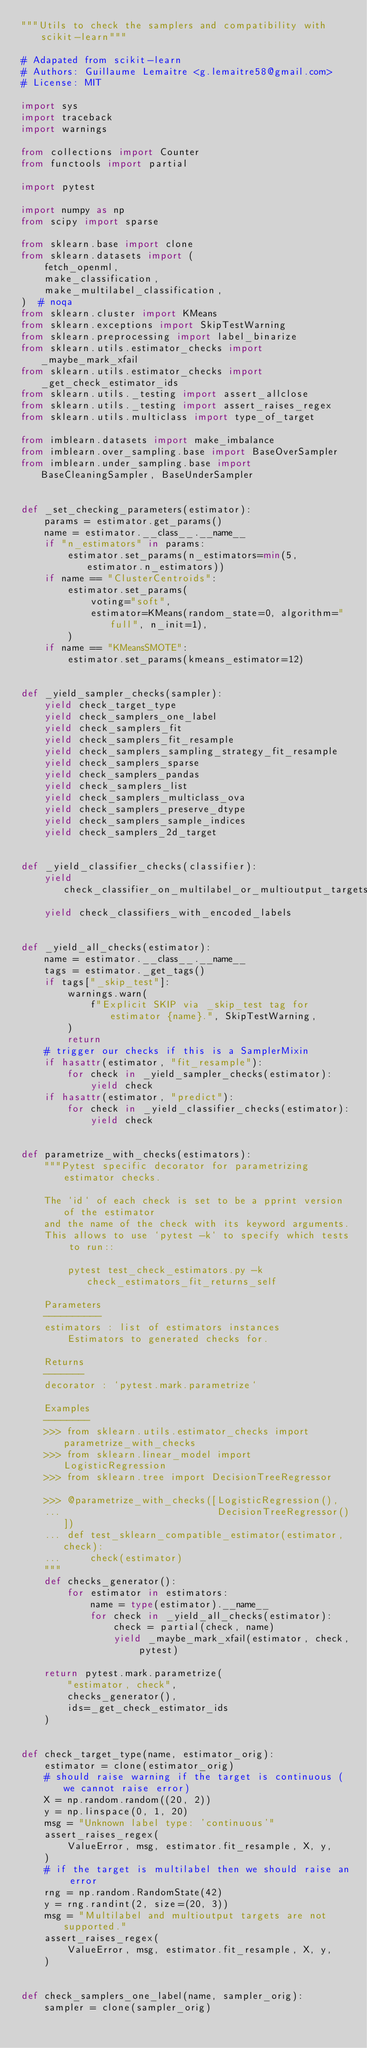<code> <loc_0><loc_0><loc_500><loc_500><_Python_>"""Utils to check the samplers and compatibility with scikit-learn"""

# Adapated from scikit-learn
# Authors: Guillaume Lemaitre <g.lemaitre58@gmail.com>
# License: MIT

import sys
import traceback
import warnings

from collections import Counter
from functools import partial

import pytest

import numpy as np
from scipy import sparse

from sklearn.base import clone
from sklearn.datasets import (
    fetch_openml,
    make_classification,
    make_multilabel_classification,
)  # noqa
from sklearn.cluster import KMeans
from sklearn.exceptions import SkipTestWarning
from sklearn.preprocessing import label_binarize
from sklearn.utils.estimator_checks import _maybe_mark_xfail
from sklearn.utils.estimator_checks import _get_check_estimator_ids
from sklearn.utils._testing import assert_allclose
from sklearn.utils._testing import assert_raises_regex
from sklearn.utils.multiclass import type_of_target

from imblearn.datasets import make_imbalance
from imblearn.over_sampling.base import BaseOverSampler
from imblearn.under_sampling.base import BaseCleaningSampler, BaseUnderSampler


def _set_checking_parameters(estimator):
    params = estimator.get_params()
    name = estimator.__class__.__name__
    if "n_estimators" in params:
        estimator.set_params(n_estimators=min(5, estimator.n_estimators))
    if name == "ClusterCentroids":
        estimator.set_params(
            voting="soft",
            estimator=KMeans(random_state=0, algorithm="full", n_init=1),
        )
    if name == "KMeansSMOTE":
        estimator.set_params(kmeans_estimator=12)


def _yield_sampler_checks(sampler):
    yield check_target_type
    yield check_samplers_one_label
    yield check_samplers_fit
    yield check_samplers_fit_resample
    yield check_samplers_sampling_strategy_fit_resample
    yield check_samplers_sparse
    yield check_samplers_pandas
    yield check_samplers_list
    yield check_samplers_multiclass_ova
    yield check_samplers_preserve_dtype
    yield check_samplers_sample_indices
    yield check_samplers_2d_target


def _yield_classifier_checks(classifier):
    yield check_classifier_on_multilabel_or_multioutput_targets
    yield check_classifiers_with_encoded_labels


def _yield_all_checks(estimator):
    name = estimator.__class__.__name__
    tags = estimator._get_tags()
    if tags["_skip_test"]:
        warnings.warn(
            f"Explicit SKIP via _skip_test tag for estimator {name}.", SkipTestWarning,
        )
        return
    # trigger our checks if this is a SamplerMixin
    if hasattr(estimator, "fit_resample"):
        for check in _yield_sampler_checks(estimator):
            yield check
    if hasattr(estimator, "predict"):
        for check in _yield_classifier_checks(estimator):
            yield check


def parametrize_with_checks(estimators):
    """Pytest specific decorator for parametrizing estimator checks.

    The `id` of each check is set to be a pprint version of the estimator
    and the name of the check with its keyword arguments.
    This allows to use `pytest -k` to specify which tests to run::

        pytest test_check_estimators.py -k check_estimators_fit_returns_self

    Parameters
    ----------
    estimators : list of estimators instances
        Estimators to generated checks for.

    Returns
    -------
    decorator : `pytest.mark.parametrize`

    Examples
    --------
    >>> from sklearn.utils.estimator_checks import parametrize_with_checks
    >>> from sklearn.linear_model import LogisticRegression
    >>> from sklearn.tree import DecisionTreeRegressor

    >>> @parametrize_with_checks([LogisticRegression(),
    ...                           DecisionTreeRegressor()])
    ... def test_sklearn_compatible_estimator(estimator, check):
    ...     check(estimator)
    """
    def checks_generator():
        for estimator in estimators:
            name = type(estimator).__name__
            for check in _yield_all_checks(estimator):
                check = partial(check, name)
                yield _maybe_mark_xfail(estimator, check, pytest)

    return pytest.mark.parametrize(
        "estimator, check",
        checks_generator(),
        ids=_get_check_estimator_ids
    )


def check_target_type(name, estimator_orig):
    estimator = clone(estimator_orig)
    # should raise warning if the target is continuous (we cannot raise error)
    X = np.random.random((20, 2))
    y = np.linspace(0, 1, 20)
    msg = "Unknown label type: 'continuous'"
    assert_raises_regex(
        ValueError, msg, estimator.fit_resample, X, y,
    )
    # if the target is multilabel then we should raise an error
    rng = np.random.RandomState(42)
    y = rng.randint(2, size=(20, 3))
    msg = "Multilabel and multioutput targets are not supported."
    assert_raises_regex(
        ValueError, msg, estimator.fit_resample, X, y,
    )


def check_samplers_one_label(name, sampler_orig):
    sampler = clone(sampler_orig)</code> 